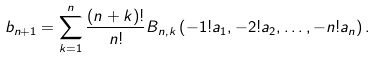<formula> <loc_0><loc_0><loc_500><loc_500>b _ { n + 1 } & = \sum _ { k = 1 } ^ { n } \frac { ( n + k ) ! } { n ! } B _ { n , k } \left ( - 1 ! a _ { 1 } , - 2 ! a _ { 2 } , \dots , - n ! a _ { n } \right ) .</formula> 